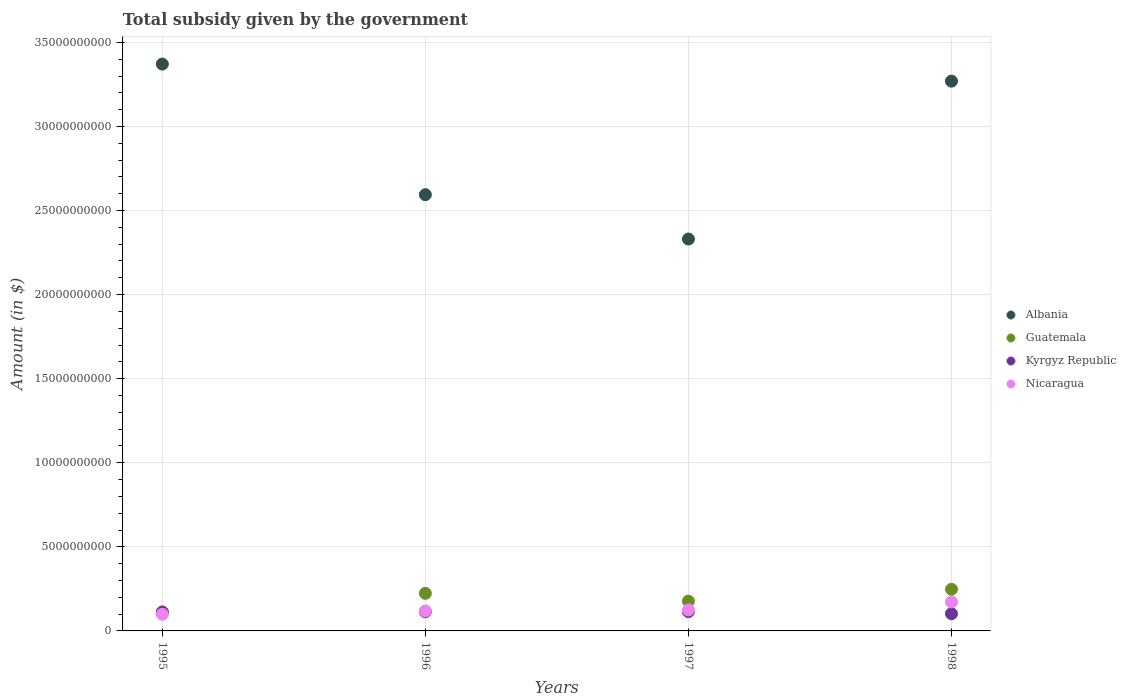What is the total revenue collected by the government in Kyrgyz Republic in 1995?
Offer a terse response. 1.10e+09. Across all years, what is the maximum total revenue collected by the government in Kyrgyz Republic?
Give a very brief answer. 1.15e+09. Across all years, what is the minimum total revenue collected by the government in Albania?
Keep it short and to the point. 2.33e+1. In which year was the total revenue collected by the government in Kyrgyz Republic minimum?
Your answer should be compact. 1998. What is the total total revenue collected by the government in Albania in the graph?
Provide a short and direct response. 1.16e+11. What is the difference between the total revenue collected by the government in Nicaragua in 1995 and that in 1996?
Keep it short and to the point. -1.95e+08. What is the difference between the total revenue collected by the government in Nicaragua in 1998 and the total revenue collected by the government in Albania in 1996?
Your response must be concise. -2.42e+1. What is the average total revenue collected by the government in Albania per year?
Your response must be concise. 2.89e+1. In the year 1998, what is the difference between the total revenue collected by the government in Nicaragua and total revenue collected by the government in Kyrgyz Republic?
Make the answer very short. 7.00e+08. What is the ratio of the total revenue collected by the government in Nicaragua in 1995 to that in 1998?
Provide a short and direct response. 0.58. Is the total revenue collected by the government in Guatemala in 1996 less than that in 1997?
Ensure brevity in your answer.  No. What is the difference between the highest and the second highest total revenue collected by the government in Albania?
Provide a succinct answer. 1.01e+09. What is the difference between the highest and the lowest total revenue collected by the government in Kyrgyz Republic?
Offer a very short reply. 1.22e+08. Is the sum of the total revenue collected by the government in Kyrgyz Republic in 1995 and 1998 greater than the maximum total revenue collected by the government in Nicaragua across all years?
Ensure brevity in your answer.  Yes. Is it the case that in every year, the sum of the total revenue collected by the government in Albania and total revenue collected by the government in Nicaragua  is greater than the sum of total revenue collected by the government in Guatemala and total revenue collected by the government in Kyrgyz Republic?
Your answer should be very brief. Yes. Is the total revenue collected by the government in Albania strictly greater than the total revenue collected by the government in Guatemala over the years?
Provide a succinct answer. Yes. How many dotlines are there?
Your answer should be very brief. 4. What is the difference between two consecutive major ticks on the Y-axis?
Provide a succinct answer. 5.00e+09. Does the graph contain any zero values?
Offer a terse response. No. Where does the legend appear in the graph?
Offer a terse response. Center right. How are the legend labels stacked?
Offer a terse response. Vertical. What is the title of the graph?
Your answer should be compact. Total subsidy given by the government. What is the label or title of the X-axis?
Offer a very short reply. Years. What is the label or title of the Y-axis?
Offer a very short reply. Amount (in $). What is the Amount (in $) of Albania in 1995?
Your answer should be very brief. 3.37e+1. What is the Amount (in $) in Guatemala in 1995?
Offer a very short reply. 1.13e+09. What is the Amount (in $) of Kyrgyz Republic in 1995?
Offer a very short reply. 1.10e+09. What is the Amount (in $) of Nicaragua in 1995?
Your answer should be very brief. 9.92e+08. What is the Amount (in $) in Albania in 1996?
Your response must be concise. 2.59e+1. What is the Amount (in $) of Guatemala in 1996?
Give a very brief answer. 2.24e+09. What is the Amount (in $) of Kyrgyz Republic in 1996?
Provide a short and direct response. 1.14e+09. What is the Amount (in $) in Nicaragua in 1996?
Your answer should be compact. 1.19e+09. What is the Amount (in $) of Albania in 1997?
Your answer should be compact. 2.33e+1. What is the Amount (in $) in Guatemala in 1997?
Your answer should be very brief. 1.77e+09. What is the Amount (in $) of Kyrgyz Republic in 1997?
Your answer should be compact. 1.15e+09. What is the Amount (in $) of Nicaragua in 1997?
Keep it short and to the point. 1.25e+09. What is the Amount (in $) of Albania in 1998?
Offer a very short reply. 3.27e+1. What is the Amount (in $) of Guatemala in 1998?
Your answer should be very brief. 2.48e+09. What is the Amount (in $) in Kyrgyz Republic in 1998?
Ensure brevity in your answer.  1.02e+09. What is the Amount (in $) of Nicaragua in 1998?
Keep it short and to the point. 1.72e+09. Across all years, what is the maximum Amount (in $) of Albania?
Offer a terse response. 3.37e+1. Across all years, what is the maximum Amount (in $) in Guatemala?
Provide a succinct answer. 2.48e+09. Across all years, what is the maximum Amount (in $) in Kyrgyz Republic?
Give a very brief answer. 1.15e+09. Across all years, what is the maximum Amount (in $) in Nicaragua?
Ensure brevity in your answer.  1.72e+09. Across all years, what is the minimum Amount (in $) in Albania?
Your answer should be compact. 2.33e+1. Across all years, what is the minimum Amount (in $) of Guatemala?
Your answer should be compact. 1.13e+09. Across all years, what is the minimum Amount (in $) of Kyrgyz Republic?
Offer a terse response. 1.02e+09. Across all years, what is the minimum Amount (in $) in Nicaragua?
Keep it short and to the point. 9.92e+08. What is the total Amount (in $) in Albania in the graph?
Your answer should be compact. 1.16e+11. What is the total Amount (in $) of Guatemala in the graph?
Your answer should be very brief. 7.62e+09. What is the total Amount (in $) of Kyrgyz Republic in the graph?
Provide a short and direct response. 4.41e+09. What is the total Amount (in $) in Nicaragua in the graph?
Offer a terse response. 5.15e+09. What is the difference between the Amount (in $) in Albania in 1995 and that in 1996?
Provide a succinct answer. 7.77e+09. What is the difference between the Amount (in $) in Guatemala in 1995 and that in 1996?
Your response must be concise. -1.10e+09. What is the difference between the Amount (in $) in Kyrgyz Republic in 1995 and that in 1996?
Give a very brief answer. -4.33e+07. What is the difference between the Amount (in $) in Nicaragua in 1995 and that in 1996?
Keep it short and to the point. -1.95e+08. What is the difference between the Amount (in $) in Albania in 1995 and that in 1997?
Give a very brief answer. 1.04e+1. What is the difference between the Amount (in $) in Guatemala in 1995 and that in 1997?
Provide a succinct answer. -6.37e+08. What is the difference between the Amount (in $) of Kyrgyz Republic in 1995 and that in 1997?
Keep it short and to the point. -4.83e+07. What is the difference between the Amount (in $) of Nicaragua in 1995 and that in 1997?
Offer a terse response. -2.54e+08. What is the difference between the Amount (in $) of Albania in 1995 and that in 1998?
Ensure brevity in your answer.  1.01e+09. What is the difference between the Amount (in $) in Guatemala in 1995 and that in 1998?
Keep it short and to the point. -1.34e+09. What is the difference between the Amount (in $) of Kyrgyz Republic in 1995 and that in 1998?
Offer a very short reply. 7.40e+07. What is the difference between the Amount (in $) of Nicaragua in 1995 and that in 1998?
Your response must be concise. -7.32e+08. What is the difference between the Amount (in $) in Albania in 1996 and that in 1997?
Keep it short and to the point. 2.64e+09. What is the difference between the Amount (in $) of Guatemala in 1996 and that in 1997?
Your answer should be compact. 4.65e+08. What is the difference between the Amount (in $) of Kyrgyz Republic in 1996 and that in 1997?
Offer a terse response. -5.00e+06. What is the difference between the Amount (in $) in Nicaragua in 1996 and that in 1997?
Make the answer very short. -5.96e+07. What is the difference between the Amount (in $) of Albania in 1996 and that in 1998?
Provide a short and direct response. -6.75e+09. What is the difference between the Amount (in $) of Guatemala in 1996 and that in 1998?
Your answer should be compact. -2.41e+08. What is the difference between the Amount (in $) of Kyrgyz Republic in 1996 and that in 1998?
Your answer should be very brief. 1.17e+08. What is the difference between the Amount (in $) of Nicaragua in 1996 and that in 1998?
Your answer should be compact. -5.37e+08. What is the difference between the Amount (in $) of Albania in 1997 and that in 1998?
Ensure brevity in your answer.  -9.39e+09. What is the difference between the Amount (in $) in Guatemala in 1997 and that in 1998?
Keep it short and to the point. -7.06e+08. What is the difference between the Amount (in $) in Kyrgyz Republic in 1997 and that in 1998?
Ensure brevity in your answer.  1.22e+08. What is the difference between the Amount (in $) in Nicaragua in 1997 and that in 1998?
Give a very brief answer. -4.78e+08. What is the difference between the Amount (in $) of Albania in 1995 and the Amount (in $) of Guatemala in 1996?
Provide a short and direct response. 3.15e+1. What is the difference between the Amount (in $) in Albania in 1995 and the Amount (in $) in Kyrgyz Republic in 1996?
Your answer should be very brief. 3.26e+1. What is the difference between the Amount (in $) in Albania in 1995 and the Amount (in $) in Nicaragua in 1996?
Provide a succinct answer. 3.25e+1. What is the difference between the Amount (in $) of Guatemala in 1995 and the Amount (in $) of Kyrgyz Republic in 1996?
Provide a short and direct response. -7.32e+06. What is the difference between the Amount (in $) of Guatemala in 1995 and the Amount (in $) of Nicaragua in 1996?
Give a very brief answer. -5.30e+07. What is the difference between the Amount (in $) in Kyrgyz Republic in 1995 and the Amount (in $) in Nicaragua in 1996?
Ensure brevity in your answer.  -8.90e+07. What is the difference between the Amount (in $) of Albania in 1995 and the Amount (in $) of Guatemala in 1997?
Make the answer very short. 3.19e+1. What is the difference between the Amount (in $) of Albania in 1995 and the Amount (in $) of Kyrgyz Republic in 1997?
Provide a succinct answer. 3.26e+1. What is the difference between the Amount (in $) in Albania in 1995 and the Amount (in $) in Nicaragua in 1997?
Your answer should be very brief. 3.25e+1. What is the difference between the Amount (in $) in Guatemala in 1995 and the Amount (in $) in Kyrgyz Republic in 1997?
Offer a terse response. -1.23e+07. What is the difference between the Amount (in $) of Guatemala in 1995 and the Amount (in $) of Nicaragua in 1997?
Provide a succinct answer. -1.13e+08. What is the difference between the Amount (in $) in Kyrgyz Republic in 1995 and the Amount (in $) in Nicaragua in 1997?
Ensure brevity in your answer.  -1.49e+08. What is the difference between the Amount (in $) in Albania in 1995 and the Amount (in $) in Guatemala in 1998?
Offer a terse response. 3.12e+1. What is the difference between the Amount (in $) of Albania in 1995 and the Amount (in $) of Kyrgyz Republic in 1998?
Offer a very short reply. 3.27e+1. What is the difference between the Amount (in $) in Albania in 1995 and the Amount (in $) in Nicaragua in 1998?
Ensure brevity in your answer.  3.20e+1. What is the difference between the Amount (in $) of Guatemala in 1995 and the Amount (in $) of Kyrgyz Republic in 1998?
Give a very brief answer. 1.10e+08. What is the difference between the Amount (in $) of Guatemala in 1995 and the Amount (in $) of Nicaragua in 1998?
Give a very brief answer. -5.90e+08. What is the difference between the Amount (in $) of Kyrgyz Republic in 1995 and the Amount (in $) of Nicaragua in 1998?
Make the answer very short. -6.26e+08. What is the difference between the Amount (in $) of Albania in 1996 and the Amount (in $) of Guatemala in 1997?
Offer a terse response. 2.42e+1. What is the difference between the Amount (in $) of Albania in 1996 and the Amount (in $) of Kyrgyz Republic in 1997?
Make the answer very short. 2.48e+1. What is the difference between the Amount (in $) of Albania in 1996 and the Amount (in $) of Nicaragua in 1997?
Your answer should be compact. 2.47e+1. What is the difference between the Amount (in $) of Guatemala in 1996 and the Amount (in $) of Kyrgyz Republic in 1997?
Your answer should be very brief. 1.09e+09. What is the difference between the Amount (in $) in Guatemala in 1996 and the Amount (in $) in Nicaragua in 1997?
Give a very brief answer. 9.89e+08. What is the difference between the Amount (in $) in Kyrgyz Republic in 1996 and the Amount (in $) in Nicaragua in 1997?
Offer a terse response. -1.05e+08. What is the difference between the Amount (in $) in Albania in 1996 and the Amount (in $) in Guatemala in 1998?
Your answer should be compact. 2.35e+1. What is the difference between the Amount (in $) in Albania in 1996 and the Amount (in $) in Kyrgyz Republic in 1998?
Your answer should be compact. 2.49e+1. What is the difference between the Amount (in $) in Albania in 1996 and the Amount (in $) in Nicaragua in 1998?
Your answer should be very brief. 2.42e+1. What is the difference between the Amount (in $) of Guatemala in 1996 and the Amount (in $) of Kyrgyz Republic in 1998?
Offer a very short reply. 1.21e+09. What is the difference between the Amount (in $) of Guatemala in 1996 and the Amount (in $) of Nicaragua in 1998?
Offer a terse response. 5.11e+08. What is the difference between the Amount (in $) in Kyrgyz Republic in 1996 and the Amount (in $) in Nicaragua in 1998?
Your answer should be compact. -5.83e+08. What is the difference between the Amount (in $) of Albania in 1997 and the Amount (in $) of Guatemala in 1998?
Your response must be concise. 2.08e+1. What is the difference between the Amount (in $) of Albania in 1997 and the Amount (in $) of Kyrgyz Republic in 1998?
Make the answer very short. 2.23e+1. What is the difference between the Amount (in $) of Albania in 1997 and the Amount (in $) of Nicaragua in 1998?
Your answer should be compact. 2.16e+1. What is the difference between the Amount (in $) of Guatemala in 1997 and the Amount (in $) of Kyrgyz Republic in 1998?
Make the answer very short. 7.47e+08. What is the difference between the Amount (in $) in Guatemala in 1997 and the Amount (in $) in Nicaragua in 1998?
Give a very brief answer. 4.66e+07. What is the difference between the Amount (in $) in Kyrgyz Republic in 1997 and the Amount (in $) in Nicaragua in 1998?
Make the answer very short. -5.78e+08. What is the average Amount (in $) of Albania per year?
Ensure brevity in your answer.  2.89e+1. What is the average Amount (in $) in Guatemala per year?
Ensure brevity in your answer.  1.90e+09. What is the average Amount (in $) in Kyrgyz Republic per year?
Keep it short and to the point. 1.10e+09. What is the average Amount (in $) in Nicaragua per year?
Keep it short and to the point. 1.29e+09. In the year 1995, what is the difference between the Amount (in $) in Albania and Amount (in $) in Guatemala?
Provide a succinct answer. 3.26e+1. In the year 1995, what is the difference between the Amount (in $) in Albania and Amount (in $) in Kyrgyz Republic?
Offer a very short reply. 3.26e+1. In the year 1995, what is the difference between the Amount (in $) of Albania and Amount (in $) of Nicaragua?
Ensure brevity in your answer.  3.27e+1. In the year 1995, what is the difference between the Amount (in $) of Guatemala and Amount (in $) of Kyrgyz Republic?
Make the answer very short. 3.60e+07. In the year 1995, what is the difference between the Amount (in $) in Guatemala and Amount (in $) in Nicaragua?
Offer a terse response. 1.42e+08. In the year 1995, what is the difference between the Amount (in $) of Kyrgyz Republic and Amount (in $) of Nicaragua?
Offer a terse response. 1.06e+08. In the year 1996, what is the difference between the Amount (in $) of Albania and Amount (in $) of Guatemala?
Keep it short and to the point. 2.37e+1. In the year 1996, what is the difference between the Amount (in $) in Albania and Amount (in $) in Kyrgyz Republic?
Your response must be concise. 2.48e+1. In the year 1996, what is the difference between the Amount (in $) in Albania and Amount (in $) in Nicaragua?
Make the answer very short. 2.48e+1. In the year 1996, what is the difference between the Amount (in $) in Guatemala and Amount (in $) in Kyrgyz Republic?
Provide a succinct answer. 1.09e+09. In the year 1996, what is the difference between the Amount (in $) in Guatemala and Amount (in $) in Nicaragua?
Your answer should be compact. 1.05e+09. In the year 1996, what is the difference between the Amount (in $) of Kyrgyz Republic and Amount (in $) of Nicaragua?
Ensure brevity in your answer.  -4.57e+07. In the year 1997, what is the difference between the Amount (in $) in Albania and Amount (in $) in Guatemala?
Keep it short and to the point. 2.15e+1. In the year 1997, what is the difference between the Amount (in $) of Albania and Amount (in $) of Kyrgyz Republic?
Your answer should be very brief. 2.22e+1. In the year 1997, what is the difference between the Amount (in $) of Albania and Amount (in $) of Nicaragua?
Provide a short and direct response. 2.21e+1. In the year 1997, what is the difference between the Amount (in $) of Guatemala and Amount (in $) of Kyrgyz Republic?
Provide a succinct answer. 6.25e+08. In the year 1997, what is the difference between the Amount (in $) of Guatemala and Amount (in $) of Nicaragua?
Ensure brevity in your answer.  5.24e+08. In the year 1997, what is the difference between the Amount (in $) in Kyrgyz Republic and Amount (in $) in Nicaragua?
Provide a short and direct response. -1.00e+08. In the year 1998, what is the difference between the Amount (in $) of Albania and Amount (in $) of Guatemala?
Offer a terse response. 3.02e+1. In the year 1998, what is the difference between the Amount (in $) in Albania and Amount (in $) in Kyrgyz Republic?
Your answer should be compact. 3.17e+1. In the year 1998, what is the difference between the Amount (in $) in Albania and Amount (in $) in Nicaragua?
Keep it short and to the point. 3.10e+1. In the year 1998, what is the difference between the Amount (in $) of Guatemala and Amount (in $) of Kyrgyz Republic?
Ensure brevity in your answer.  1.45e+09. In the year 1998, what is the difference between the Amount (in $) of Guatemala and Amount (in $) of Nicaragua?
Make the answer very short. 7.53e+08. In the year 1998, what is the difference between the Amount (in $) of Kyrgyz Republic and Amount (in $) of Nicaragua?
Ensure brevity in your answer.  -7.00e+08. What is the ratio of the Amount (in $) of Albania in 1995 to that in 1996?
Offer a terse response. 1.3. What is the ratio of the Amount (in $) of Guatemala in 1995 to that in 1996?
Ensure brevity in your answer.  0.51. What is the ratio of the Amount (in $) in Kyrgyz Republic in 1995 to that in 1996?
Provide a succinct answer. 0.96. What is the ratio of the Amount (in $) of Nicaragua in 1995 to that in 1996?
Offer a very short reply. 0.84. What is the ratio of the Amount (in $) in Albania in 1995 to that in 1997?
Your answer should be compact. 1.45. What is the ratio of the Amount (in $) of Guatemala in 1995 to that in 1997?
Provide a short and direct response. 0.64. What is the ratio of the Amount (in $) of Kyrgyz Republic in 1995 to that in 1997?
Offer a terse response. 0.96. What is the ratio of the Amount (in $) of Nicaragua in 1995 to that in 1997?
Ensure brevity in your answer.  0.8. What is the ratio of the Amount (in $) of Albania in 1995 to that in 1998?
Your answer should be compact. 1.03. What is the ratio of the Amount (in $) of Guatemala in 1995 to that in 1998?
Offer a terse response. 0.46. What is the ratio of the Amount (in $) of Kyrgyz Republic in 1995 to that in 1998?
Offer a very short reply. 1.07. What is the ratio of the Amount (in $) in Nicaragua in 1995 to that in 1998?
Keep it short and to the point. 0.58. What is the ratio of the Amount (in $) in Albania in 1996 to that in 1997?
Your response must be concise. 1.11. What is the ratio of the Amount (in $) in Guatemala in 1996 to that in 1997?
Ensure brevity in your answer.  1.26. What is the ratio of the Amount (in $) in Nicaragua in 1996 to that in 1997?
Keep it short and to the point. 0.95. What is the ratio of the Amount (in $) of Albania in 1996 to that in 1998?
Your answer should be compact. 0.79. What is the ratio of the Amount (in $) in Guatemala in 1996 to that in 1998?
Your response must be concise. 0.9. What is the ratio of the Amount (in $) of Kyrgyz Republic in 1996 to that in 1998?
Your answer should be compact. 1.11. What is the ratio of the Amount (in $) in Nicaragua in 1996 to that in 1998?
Offer a terse response. 0.69. What is the ratio of the Amount (in $) of Albania in 1997 to that in 1998?
Offer a very short reply. 0.71. What is the ratio of the Amount (in $) of Guatemala in 1997 to that in 1998?
Provide a short and direct response. 0.71. What is the ratio of the Amount (in $) of Kyrgyz Republic in 1997 to that in 1998?
Offer a very short reply. 1.12. What is the ratio of the Amount (in $) in Nicaragua in 1997 to that in 1998?
Your response must be concise. 0.72. What is the difference between the highest and the second highest Amount (in $) of Albania?
Your answer should be very brief. 1.01e+09. What is the difference between the highest and the second highest Amount (in $) of Guatemala?
Your response must be concise. 2.41e+08. What is the difference between the highest and the second highest Amount (in $) of Kyrgyz Republic?
Give a very brief answer. 5.00e+06. What is the difference between the highest and the second highest Amount (in $) of Nicaragua?
Provide a short and direct response. 4.78e+08. What is the difference between the highest and the lowest Amount (in $) in Albania?
Offer a very short reply. 1.04e+1. What is the difference between the highest and the lowest Amount (in $) in Guatemala?
Offer a terse response. 1.34e+09. What is the difference between the highest and the lowest Amount (in $) in Kyrgyz Republic?
Your answer should be very brief. 1.22e+08. What is the difference between the highest and the lowest Amount (in $) in Nicaragua?
Provide a succinct answer. 7.32e+08. 